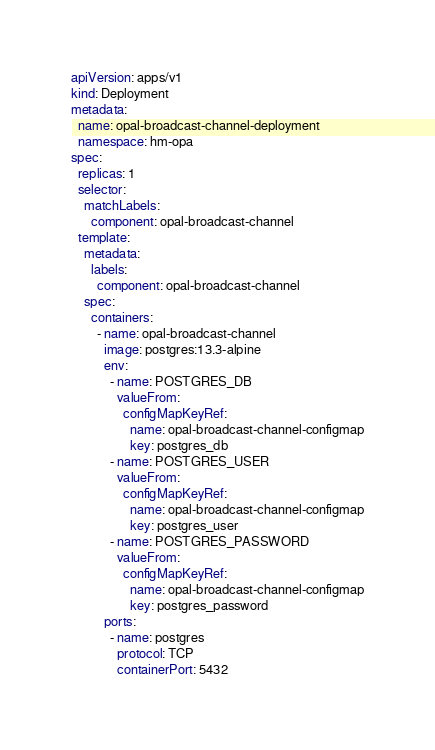<code> <loc_0><loc_0><loc_500><loc_500><_YAML_>apiVersion: apps/v1
kind: Deployment
metadata:
  name: opal-broadcast-channel-deployment
  namespace: hm-opa
spec:
  replicas: 1
  selector:
    matchLabels:
      component: opal-broadcast-channel
  template:
    metadata:
      labels:
        component: opal-broadcast-channel
    spec:
      containers:
        - name: opal-broadcast-channel
          image: postgres:13.3-alpine
          env:
            - name: POSTGRES_DB
              valueFrom:
                configMapKeyRef:
                  name: opal-broadcast-channel-configmap
                  key: postgres_db
            - name: POSTGRES_USER
              valueFrom:
                configMapKeyRef:
                  name: opal-broadcast-channel-configmap
                  key: postgres_user
            - name: POSTGRES_PASSWORD
              valueFrom:
                configMapKeyRef:
                  name: opal-broadcast-channel-configmap
                  key: postgres_password
          ports:
            - name: postgres
              protocol: TCP
              containerPort: 5432
</code> 